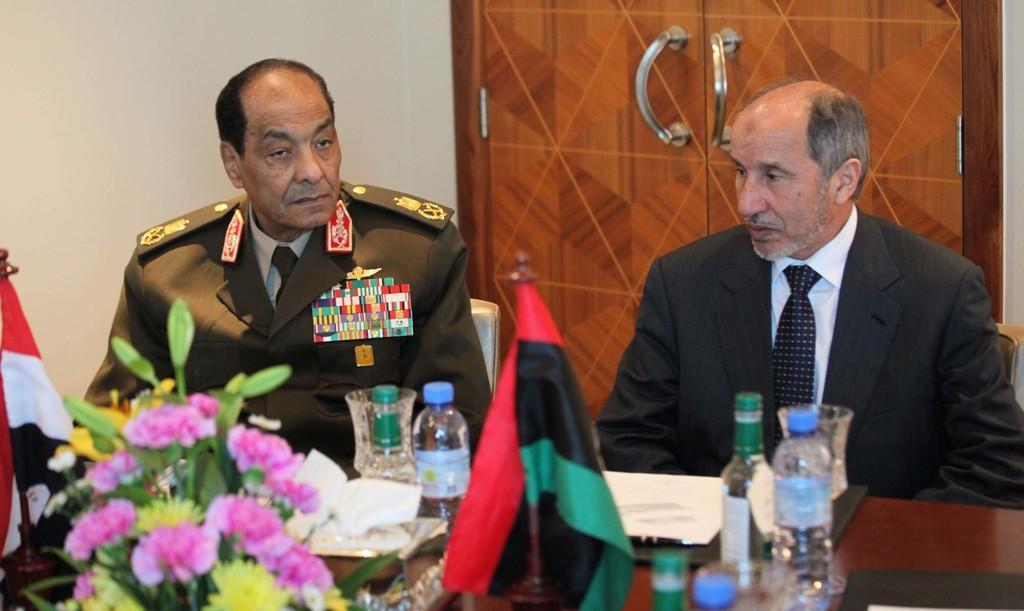Could you give a brief overview of what you see in this image? In this picture there are two men sitting on chairs and we can see flowers, bottles, glasses, flags and objects on the table. In the background of the image we can see wall and door. 